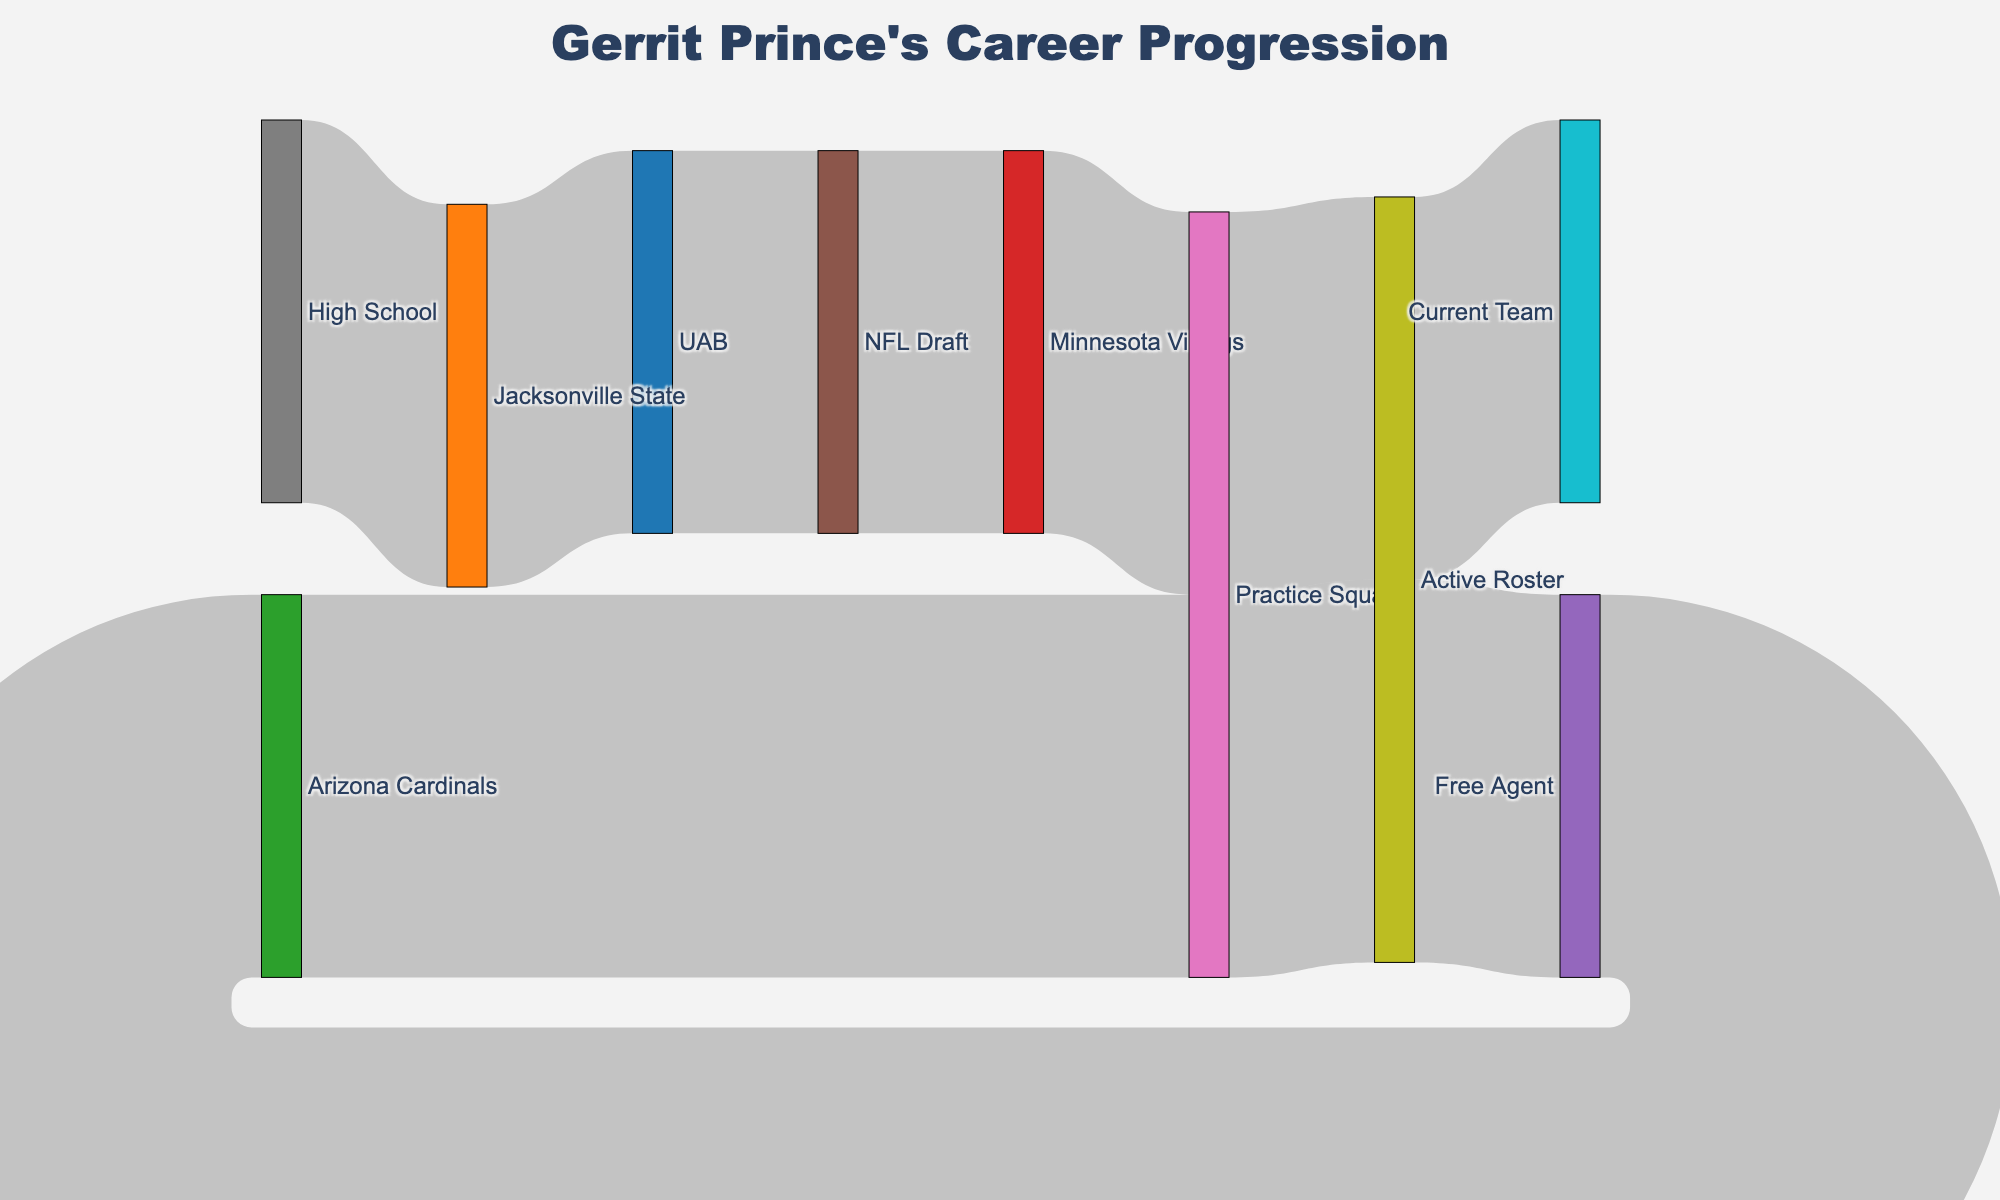How many teams did Gerrit Prince play for according to the Sankey diagram? Count the unique team names in the diagram, which are "Jacksonville State", "UAB", "Minnesota Vikings", and "Arizona Cardinals".
Answer: 4 What is the relationship between the "Practice Squad" and "Active Roster"? Identify the connections in the Sankey diagram where "Practice Squad" is the source and observe the target nodes. "Practice Squad" flows into "Active Roster".
Answer: "Practice Squad" to "Active Roster" After Gerrit Prince was drafted, which team did he join? Track the flow from "NFL Draft" and see which team it connects to in the Sankey diagram. He joined the "Minnesota Vikings".
Answer: Minnesota Vikings How many transitions are shown from "Active Roster" in the Sankey diagram? Look at the number of links that originate from "Active Roster". There are two transitions; one to "Free Agent" and another back to "Practice Squad".
Answer: 2 Where did Gerrit Prince go after being a Free Agent? Identify the flow that starts from "Free Agent" and track its target in the Sankey diagram. He went to the "Arizona Cardinals".
Answer: Arizona Cardinals What is the final team listed in Gerrit Prince's career progression? Follow the paths in the Sankey diagram all the way to the last node. The final team listed is "Current Team".
Answer: Current Team Which league was Gerrit Prince a part of before he became a Free Agent? Track the nodes leading into "Free Agent". The previous connection is "Active Roster", which is part of the professional journey but not a specific league.
Answer: Active Roster From which node does the journey in the Sankey diagram begin? Identify the first node in the flow sequence of the Sankey diagram. It begins at "High School".
Answer: High School How many times did Gerrit Prince transition back to "Practice Squad"? Count the number of times the "Practice Squad" node appears as a target in the diagram. It appears two times.
Answer: 2 Which team did Gerrit Prince join immediately after leaving the "Minnesota Vikings" Active Roster? Follow the flow from "Active Roster" after "Minnesota Vikings". From "Active Roster" of Minnesota Vikings, he becomes a Free Agent, indicating no immediate subsequent team until he joins "Arizona Cardinals".
Answer: Free Agent 